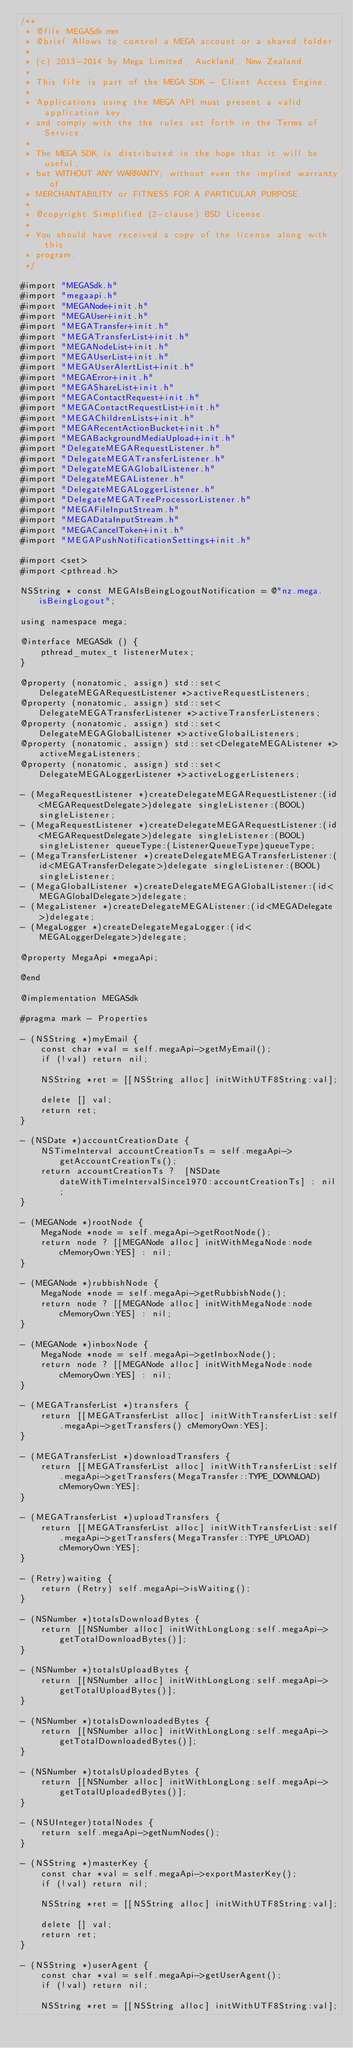<code> <loc_0><loc_0><loc_500><loc_500><_ObjectiveC_>/**
 * @file MEGASdk.mm
 * @brief Allows to control a MEGA account or a shared folder
 *
 * (c) 2013-2014 by Mega Limited, Auckland, New Zealand
 *
 * This file is part of the MEGA SDK - Client Access Engine.
 *
 * Applications using the MEGA API must present a valid application key
 * and comply with the the rules set forth in the Terms of Service.
 *
 * The MEGA SDK is distributed in the hope that it will be useful,
 * but WITHOUT ANY WARRANTY; without even the implied warranty of
 * MERCHANTABILITY or FITNESS FOR A PARTICULAR PURPOSE.
 *
 * @copyright Simplified (2-clause) BSD License.
 *
 * You should have received a copy of the license along with this
 * program.
 */

#import "MEGASdk.h"
#import "megaapi.h"
#import "MEGANode+init.h"
#import "MEGAUser+init.h"
#import "MEGATransfer+init.h"
#import "MEGATransferList+init.h"
#import "MEGANodeList+init.h"
#import "MEGAUserList+init.h"
#import "MEGAUserAlertList+init.h"
#import "MEGAError+init.h"
#import "MEGAShareList+init.h"
#import "MEGAContactRequest+init.h"
#import "MEGAContactRequestList+init.h"
#import "MEGAChildrenLists+init.h"
#import "MEGARecentActionBucket+init.h"
#import "MEGABackgroundMediaUpload+init.h"
#import "DelegateMEGARequestListener.h"
#import "DelegateMEGATransferListener.h"
#import "DelegateMEGAGlobalListener.h"
#import "DelegateMEGAListener.h"
#import "DelegateMEGALoggerListener.h"
#import "DelegateMEGATreeProcessorListener.h"
#import "MEGAFileInputStream.h"
#import "MEGADataInputStream.h"
#import "MEGACancelToken+init.h"
#import "MEGAPushNotificationSettings+init.h"

#import <set>
#import <pthread.h>

NSString * const MEGAIsBeingLogoutNotification = @"nz.mega.isBeingLogout";

using namespace mega;

@interface MEGASdk () {
    pthread_mutex_t listenerMutex;
}

@property (nonatomic, assign) std::set<DelegateMEGARequestListener *>activeRequestListeners;
@property (nonatomic, assign) std::set<DelegateMEGATransferListener *>activeTransferListeners;
@property (nonatomic, assign) std::set<DelegateMEGAGlobalListener *>activeGlobalListeners;
@property (nonatomic, assign) std::set<DelegateMEGAListener *>activeMegaListeners;
@property (nonatomic, assign) std::set<DelegateMEGALoggerListener *>activeLoggerListeners;

- (MegaRequestListener *)createDelegateMEGARequestListener:(id<MEGARequestDelegate>)delegate singleListener:(BOOL)singleListener;
- (MegaRequestListener *)createDelegateMEGARequestListener:(id<MEGARequestDelegate>)delegate singleListener:(BOOL)singleListener queueType:(ListenerQueueType)queueType;
- (MegaTransferListener *)createDelegateMEGATransferListener:(id<MEGATransferDelegate>)delegate singleListener:(BOOL)singleListener;
- (MegaGlobalListener *)createDelegateMEGAGlobalListener:(id<MEGAGlobalDelegate>)delegate;
- (MegaListener *)createDelegateMEGAListener:(id<MEGADelegate>)delegate;
- (MegaLogger *)createDelegateMegaLogger:(id<MEGALoggerDelegate>)delegate;

@property MegaApi *megaApi;

@end

@implementation MEGASdk

#pragma mark - Properties

- (NSString *)myEmail {
    const char *val = self.megaApi->getMyEmail();
    if (!val) return nil;
    
    NSString *ret = [[NSString alloc] initWithUTF8String:val];
    
    delete [] val;
    return ret;
}

- (NSDate *)accountCreationDate {
    NSTimeInterval accountCreationTs = self.megaApi->getAccountCreationTs();
    return accountCreationTs ?  [NSDate dateWithTimeIntervalSince1970:accountCreationTs] : nil;
}

- (MEGANode *)rootNode {
    MegaNode *node = self.megaApi->getRootNode();
    return node ? [[MEGANode alloc] initWithMegaNode:node cMemoryOwn:YES] : nil;
}

- (MEGANode *)rubbishNode {
    MegaNode *node = self.megaApi->getRubbishNode();
    return node ? [[MEGANode alloc] initWithMegaNode:node cMemoryOwn:YES] : nil;
}

- (MEGANode *)inboxNode {
    MegaNode *node = self.megaApi->getInboxNode();
    return node ? [[MEGANode alloc] initWithMegaNode:node cMemoryOwn:YES] : nil;
}

- (MEGATransferList *)transfers {
    return [[MEGATransferList alloc] initWithTransferList:self.megaApi->getTransfers() cMemoryOwn:YES];
}

- (MEGATransferList *)downloadTransfers {
    return [[MEGATransferList alloc] initWithTransferList:self.megaApi->getTransfers(MegaTransfer::TYPE_DOWNLOAD) cMemoryOwn:YES];
}

- (MEGATransferList *)uploadTransfers {
    return [[MEGATransferList alloc] initWithTransferList:self.megaApi->getTransfers(MegaTransfer::TYPE_UPLOAD) cMemoryOwn:YES];
}

- (Retry)waiting {
    return (Retry) self.megaApi->isWaiting();
}

- (NSNumber *)totalsDownloadBytes {
    return [[NSNumber alloc] initWithLongLong:self.megaApi->getTotalDownloadBytes()];
}

- (NSNumber *)totalsUploadBytes {
    return [[NSNumber alloc] initWithLongLong:self.megaApi->getTotalUploadBytes()];
}

- (NSNumber *)totalsDownloadedBytes {
    return [[NSNumber alloc] initWithLongLong:self.megaApi->getTotalDownloadedBytes()];
}

- (NSNumber *)totalsUploadedBytes {
    return [[NSNumber alloc] initWithLongLong:self.megaApi->getTotalUploadedBytes()];
}

- (NSUInteger)totalNodes {
    return self.megaApi->getNumNodes();
}

- (NSString *)masterKey {
    const char *val = self.megaApi->exportMasterKey();
    if (!val) return nil;
    
    NSString *ret = [[NSString alloc] initWithUTF8String:val];
    
    delete [] val;
    return ret;
}

- (NSString *)userAgent {
    const char *val = self.megaApi->getUserAgent();
    if (!val) return nil;
    
    NSString *ret = [[NSString alloc] initWithUTF8String:val];
    </code> 